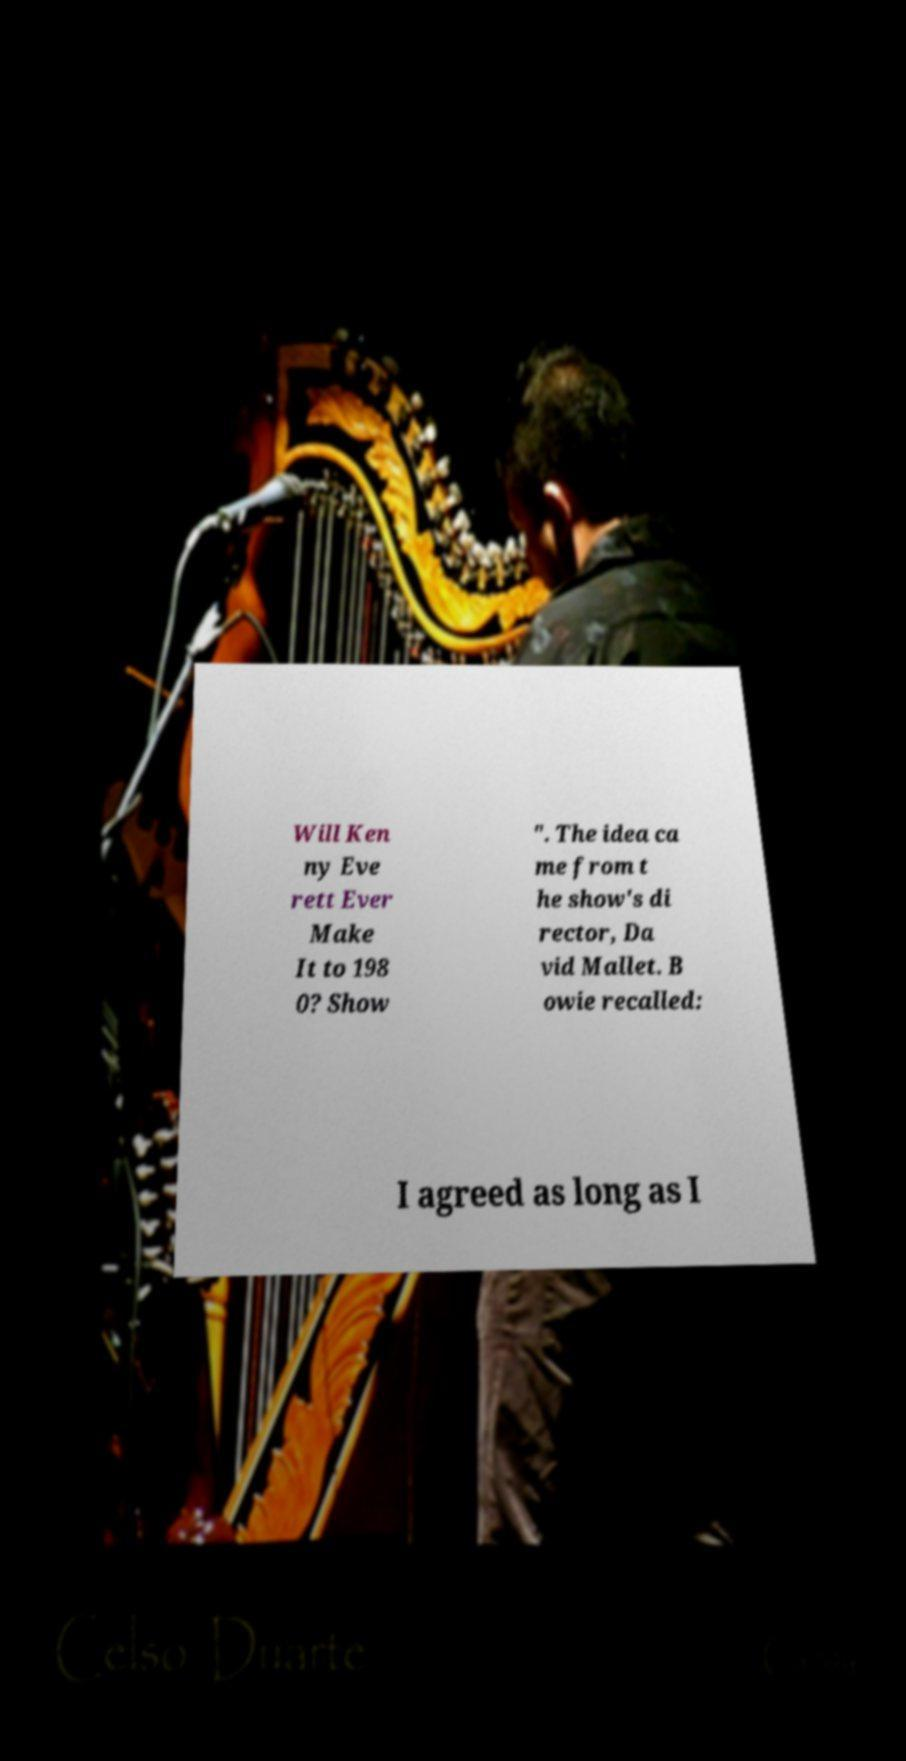Please read and relay the text visible in this image. What does it say? Will Ken ny Eve rett Ever Make It to 198 0? Show ". The idea ca me from t he show's di rector, Da vid Mallet. B owie recalled: I agreed as long as I 